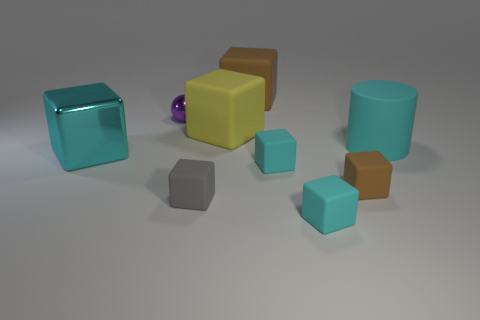There is a big object that is the same color as the large cylinder; what is it made of?
Provide a short and direct response. Metal. There is a shiny cube that is the same color as the matte cylinder; what is its size?
Offer a terse response. Large. How many small rubber blocks have the same color as the large rubber cylinder?
Give a very brief answer. 2. Do the small purple sphere and the tiny cyan block behind the small brown matte block have the same material?
Offer a terse response. No. How many other things are there of the same shape as the purple metal object?
Keep it short and to the point. 0. How many objects are things that are in front of the large cyan rubber object or things that are behind the large cylinder?
Keep it short and to the point. 8. How many other objects are the same color as the large shiny object?
Your answer should be very brief. 3. Is the number of large cyan metal things to the right of the large yellow thing less than the number of small cyan blocks to the left of the cyan metal object?
Make the answer very short. No. How many brown things are there?
Keep it short and to the point. 2. Are there any other things that are the same material as the gray thing?
Provide a succinct answer. Yes. 